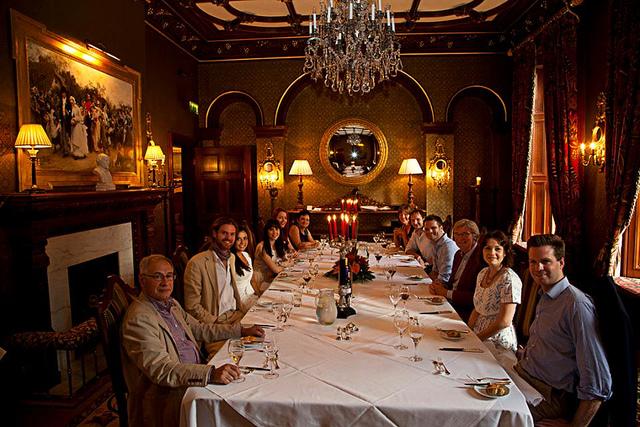What color are the chairs?
Write a very short answer. Brown. What is sitting on the table in front of the lady?
Keep it brief. Glass. Are all of the seats full?
Keep it brief. Yes. What kind of lights are behind the people?
Be succinct. Lamps. What is in the center?
Answer briefly. Candles. What room is this?
Keep it brief. Dining room. What food is on the plate?
Be succinct. None. What color is the tablecloth?
Be succinct. White. Is it dark?
Answer briefly. No. What is covering the table?
Answer briefly. Tablecloth. 